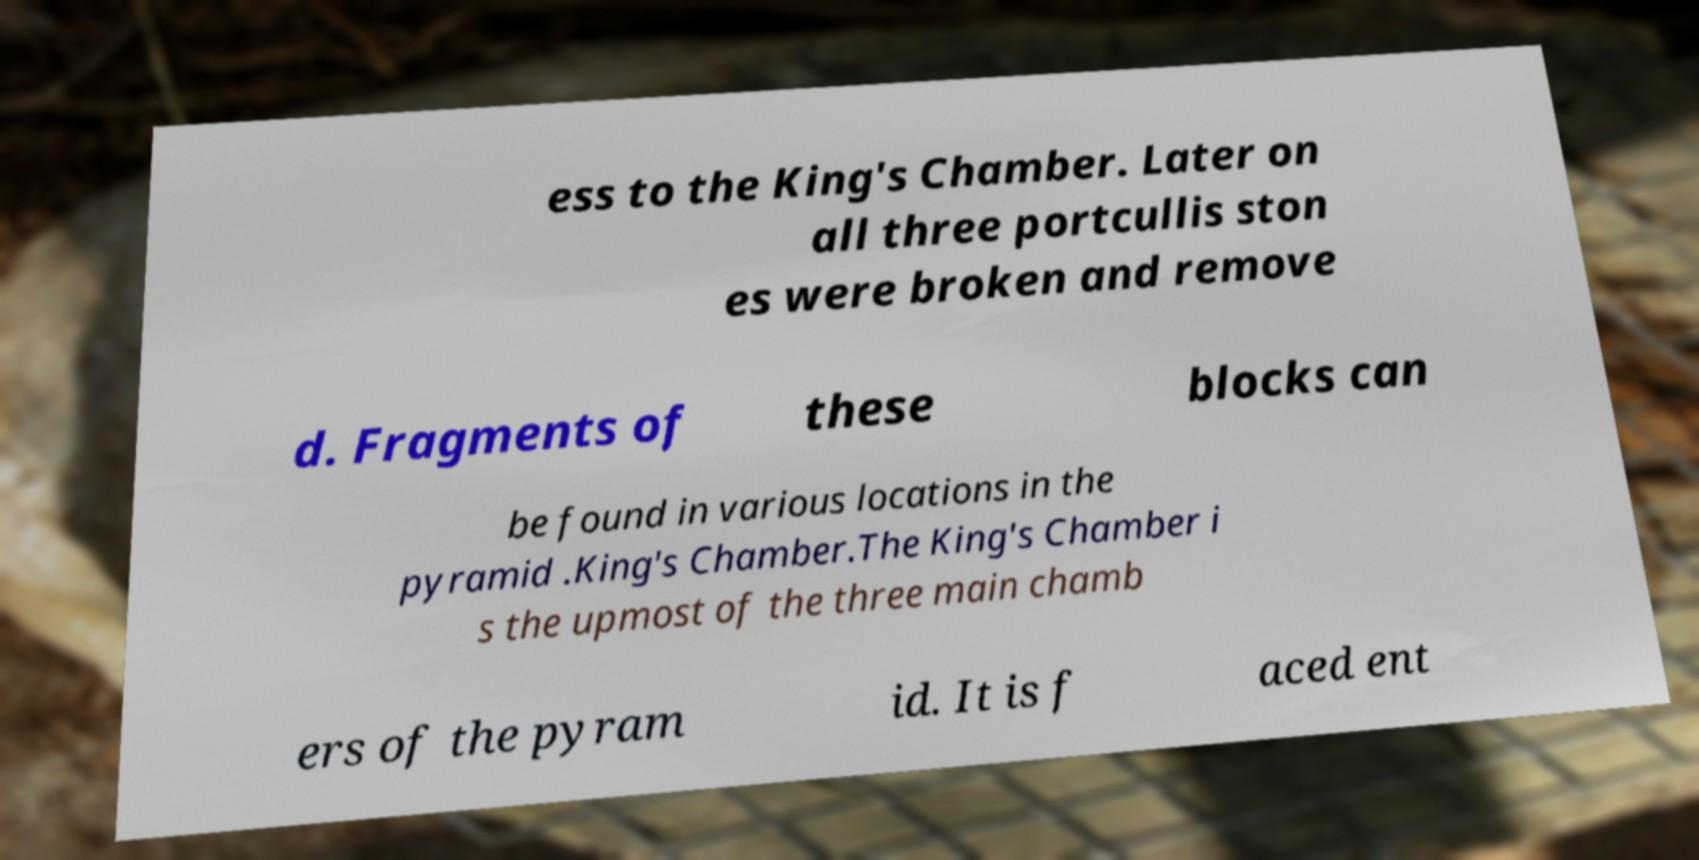For documentation purposes, I need the text within this image transcribed. Could you provide that? ess to the King's Chamber. Later on all three portcullis ston es were broken and remove d. Fragments of these blocks can be found in various locations in the pyramid .King's Chamber.The King's Chamber i s the upmost of the three main chamb ers of the pyram id. It is f aced ent 